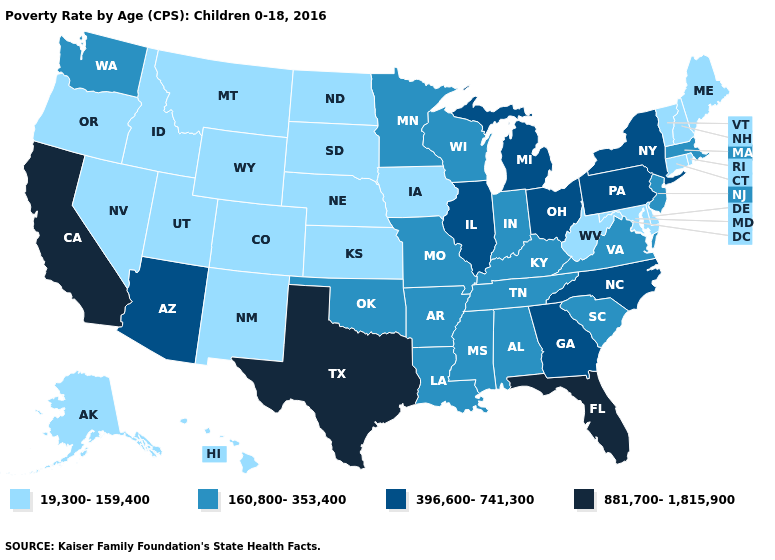Name the states that have a value in the range 160,800-353,400?
Short answer required. Alabama, Arkansas, Indiana, Kentucky, Louisiana, Massachusetts, Minnesota, Mississippi, Missouri, New Jersey, Oklahoma, South Carolina, Tennessee, Virginia, Washington, Wisconsin. What is the value of Kentucky?
Answer briefly. 160,800-353,400. Which states have the lowest value in the USA?
Answer briefly. Alaska, Colorado, Connecticut, Delaware, Hawaii, Idaho, Iowa, Kansas, Maine, Maryland, Montana, Nebraska, Nevada, New Hampshire, New Mexico, North Dakota, Oregon, Rhode Island, South Dakota, Utah, Vermont, West Virginia, Wyoming. What is the lowest value in states that border Tennessee?
Be succinct. 160,800-353,400. Name the states that have a value in the range 881,700-1,815,900?
Answer briefly. California, Florida, Texas. Among the states that border Minnesota , which have the highest value?
Write a very short answer. Wisconsin. Does the first symbol in the legend represent the smallest category?
Short answer required. Yes. Does Illinois have the highest value in the MidWest?
Quick response, please. Yes. Does the map have missing data?
Keep it brief. No. What is the lowest value in the USA?
Concise answer only. 19,300-159,400. Name the states that have a value in the range 19,300-159,400?
Be succinct. Alaska, Colorado, Connecticut, Delaware, Hawaii, Idaho, Iowa, Kansas, Maine, Maryland, Montana, Nebraska, Nevada, New Hampshire, New Mexico, North Dakota, Oregon, Rhode Island, South Dakota, Utah, Vermont, West Virginia, Wyoming. What is the highest value in the MidWest ?
Give a very brief answer. 396,600-741,300. Does South Carolina have a higher value than New Hampshire?
Give a very brief answer. Yes. Name the states that have a value in the range 19,300-159,400?
Be succinct. Alaska, Colorado, Connecticut, Delaware, Hawaii, Idaho, Iowa, Kansas, Maine, Maryland, Montana, Nebraska, Nevada, New Hampshire, New Mexico, North Dakota, Oregon, Rhode Island, South Dakota, Utah, Vermont, West Virginia, Wyoming. 